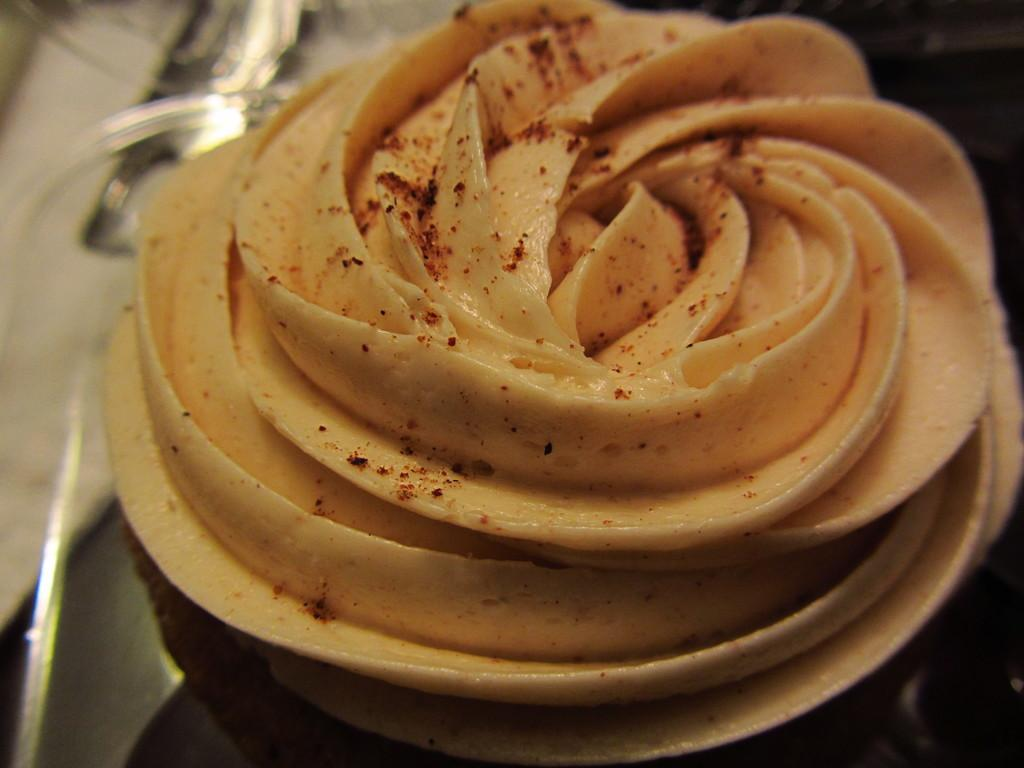What type of dessert is featured in the image? There is a buttercream cupcake in the image. Can you describe the frosting on the cupcake? The frosting on the cupcake is buttercream. What might be a common way to enjoy the cupcake in the image? The cupcake could be eaten by taking a bite or using a fork or spoon to scoop up the frosting and cake. What type of yarn is used to create the cupcake in the image? The image does not depict a cupcake made of yarn; it is a traditional buttercream cupcake. Can you tell me how many cameras are visible in the image? There are no cameras present in the image; it features a buttercream cupcake. 